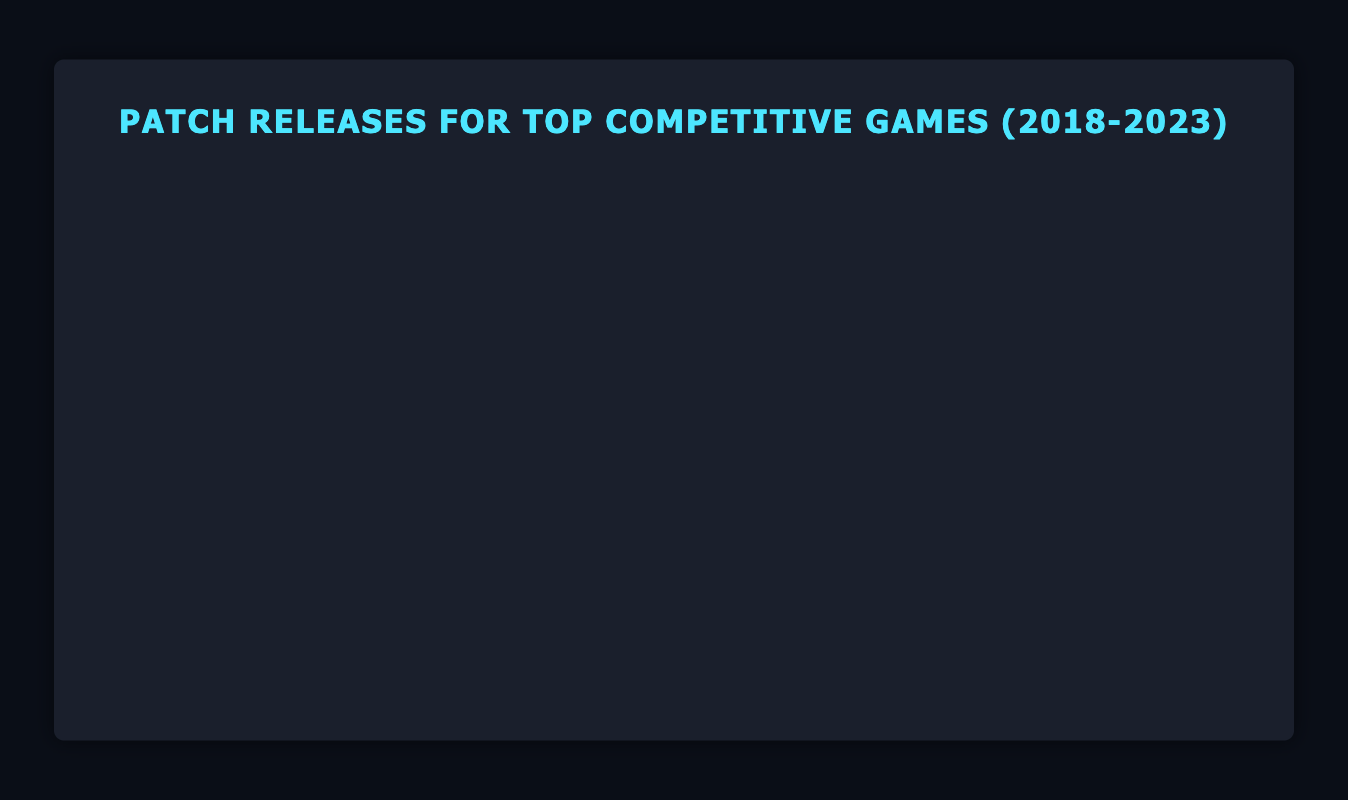What's the average number of patches for League of Legends in 2021? Sum the number of patches for League of Legends in each month of 2021: 3 + 2 + 2 + 2 + 2 + 3 = 14. Then divide by the total number of months in a year, 14 / 12 = 1.17 patches per month.
Answer: 1.17 Which game had the highest number of patches in a single month throughout 2018-2023? Check the monthly patches for each game across all years. Fortnite had the highest patches with 5 patches in May 2020, May 2023.
Answer: Fortnite For CS:GO, did the number of patches released in April 2023 increase, decrease, or stay the same compared to April 2022? Comparing April 2022 and April 2023 for CS:GO: both have 2 patches.
Answer: Same Which months and years did Overwatch have the fewest number of patches? Overwatch had the fewest patches (1 patch) in March 2021, March 2023.
Answer: March 2021, March 2023 What is the total number of patches released for Fortnite from 2018 to 2023? Sum the patches for Fortnite from each month/year: 4 + 3 + 5 + 4 + 4 + 5 + 3 + 3 + 4
Answer: 36 In which month of 2019 did Rainbow Six Siege have the highest number of patches? Check the Rainbow Six Siege data for each month of 2019. The patches are consistently the same (2 patches) in November.
Answer: November 2019 How does the number of patches for League of Legends in January 2020 compare to January 2023? January 2020 had 2 patches, and January 2023 had 3 patches for League of Legends. The number increased.
Answer: Increased Which game had the most consistent number of patches per month from 2018 to 2023? Examine the consistency by reviewing the monthly patches. Rainbow Six Siege consistently had 1 or 2 patches each month.
Answer: Rainbow Six Siege Is there a year where Dota 2 saw an increase in the number of patches each February compared to the previous year? Check the patches in February: 
2018: 1 
2019: 1 
2020: 2 
2021: 2 
2022: 2 
2023: 2.
Increase in 2020 compared to 2019.
Answer: 2020 